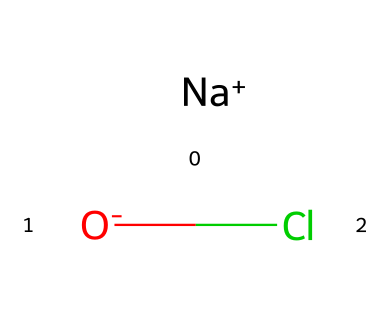What is the total number of atoms in sodium hypochlorite? The chemical structure consists of one sodium atom, one oxygen atom, and one chlorine atom. Adding these gives a total of three atoms.
Answer: three What type of bond exists between the sodium and chlorine in sodium hypochlorite? Sodium hypochlorite consists of an ionic bond between the positively charged sodium and the negatively charged chloride. Sodium donates an electron to chlorine, resulting in this ionic interaction.
Answer: ionic How many distinct elements are present in sodium hypochlorite? The structure reveals the presence of three distinct elements: sodium, oxygen, and chlorine.
Answer: three What charge does the oxygen atom carry in sodium hypochlorite? In this molecule, the oxygen atom is represented as negatively charged, which is indicated by the O- notation.
Answer: negative What role does sodium hypochlorite play in cleaning products? Sodium hypochlorite is primarily utilized as a disinfectant and bleaching agent due to its oxidative properties, which effectively kill bacteria and remove stains.
Answer: disinfectant How does sodium hypochlorite act as an oxidizer? Sodium hypochlorite contains chlorine, which can accept electrons from other substances, enabling it to oxidize them. This is a characteristic feature of oxidizers that participate in redox reactions.
Answer: oxidizing agent 